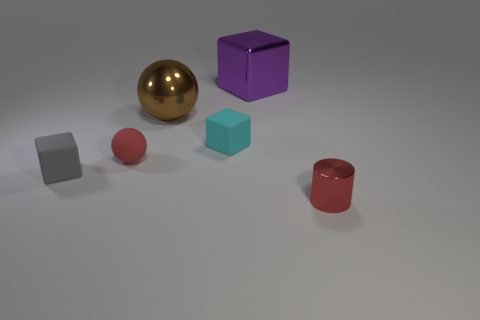Add 4 small cyan rubber things. How many objects exist? 10 Subtract all balls. How many objects are left? 4 Add 2 brown metallic spheres. How many brown metallic spheres exist? 3 Subtract 0 yellow blocks. How many objects are left? 6 Subtract all small yellow rubber things. Subtract all cyan things. How many objects are left? 5 Add 6 cylinders. How many cylinders are left? 7 